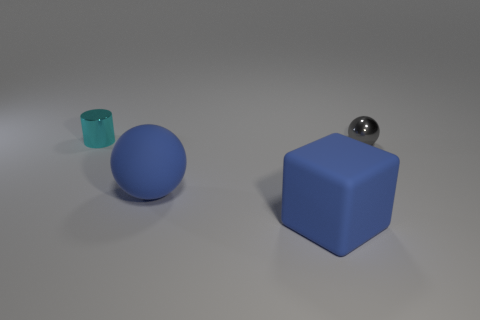Add 3 small gray shiny balls. How many objects exist? 7 Subtract all cylinders. How many objects are left? 3 Add 4 rubber spheres. How many rubber spheres are left? 5 Add 3 purple metallic cylinders. How many purple metallic cylinders exist? 3 Subtract 1 blue spheres. How many objects are left? 3 Subtract all gray shiny balls. Subtract all gray shiny objects. How many objects are left? 2 